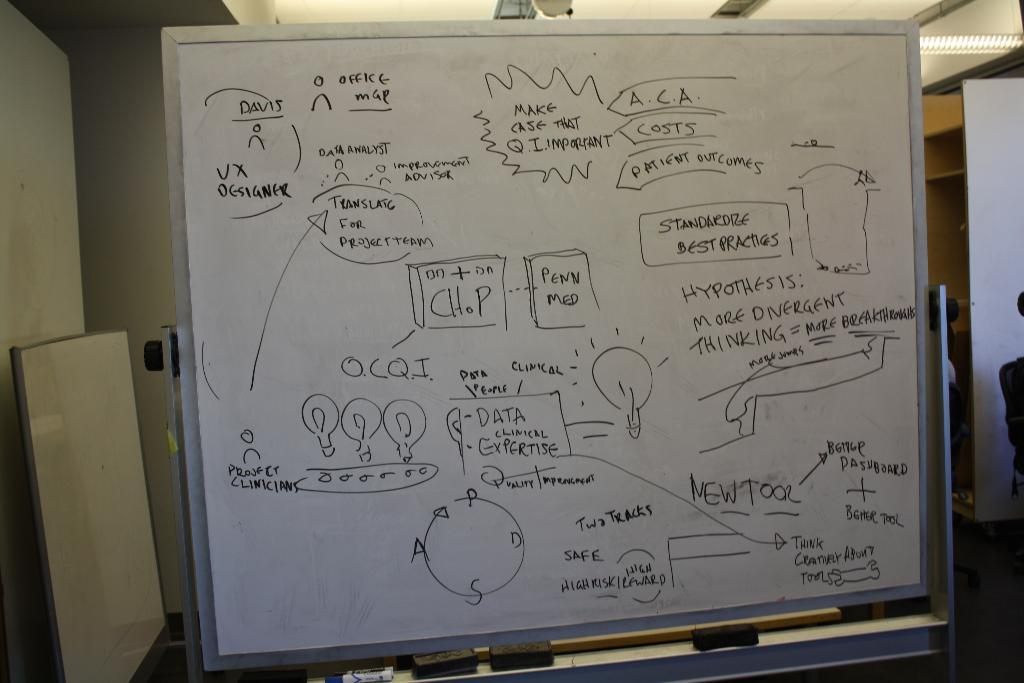<image>
Relay a brief, clear account of the picture shown. A whiteboard has text talking about patient outcomes and data. 